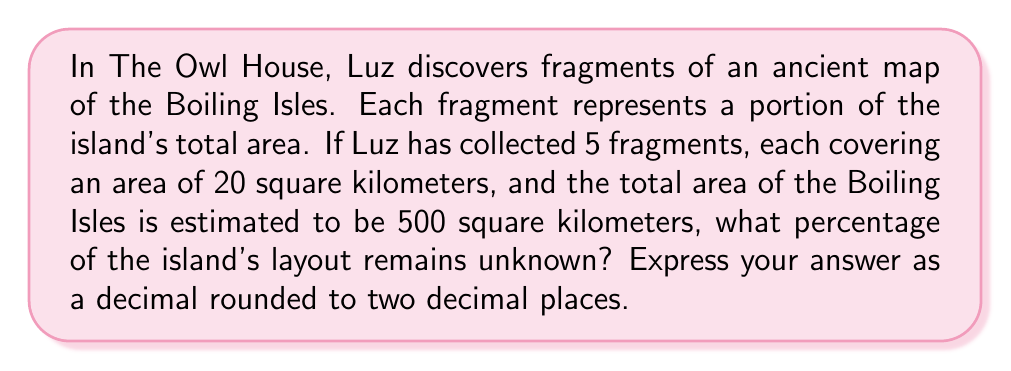Show me your answer to this math problem. Let's approach this step-by-step:

1. Calculate the total area covered by the map fragments:
   $$\text{Area covered} = \text{Number of fragments} \times \text{Area per fragment}$$
   $$\text{Area covered} = 5 \times 20 = 100 \text{ sq km}$$

2. Calculate the percentage of the island covered by the fragments:
   $$\text{Percentage covered} = \frac{\text{Area covered}}{\text{Total area of Boiling Isles}} \times 100\%$$
   $$\text{Percentage covered} = \frac{100}{500} \times 100\% = 20\%$$

3. The percentage of the island that remains unknown is the complement of the covered area:
   $$\text{Percentage unknown} = 100\% - \text{Percentage covered}$$
   $$\text{Percentage unknown} = 100\% - 20\% = 80\%$$

4. Convert the percentage to a decimal:
   $$80\% = 0.80$$

Therefore, 80% or 0.80 of the island's layout remains unknown.
Answer: 0.80 